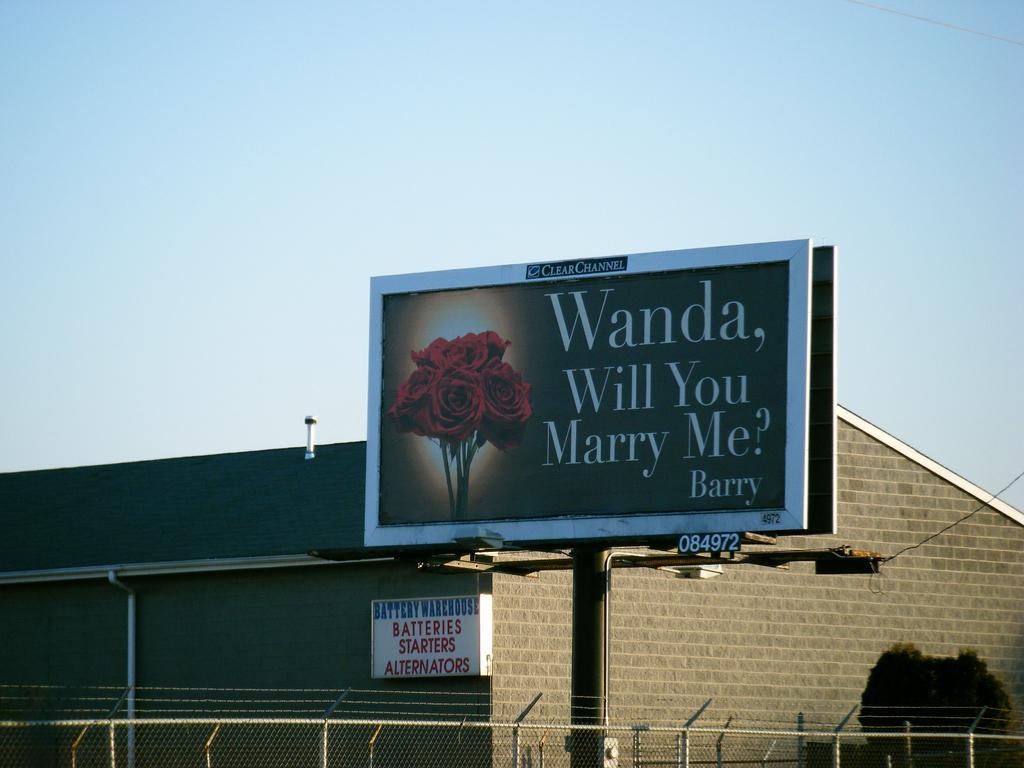Could you give a brief overview of what you see in this image? In this image there is a board with some text attached to the pole, there is a fence, building, a board attached to the wall of the building and an object at the top of the roof, a tree and the sky. 